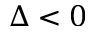<formula> <loc_0><loc_0><loc_500><loc_500>\Delta < 0</formula> 